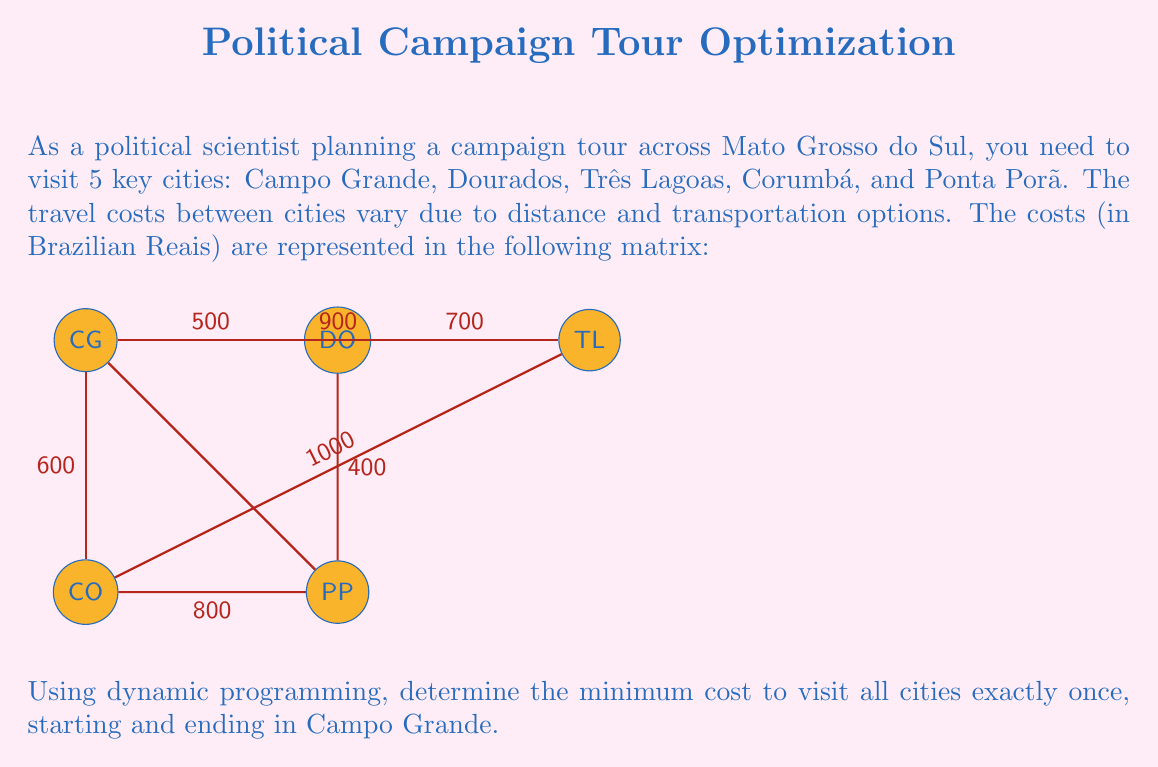Help me with this question. To solve this problem using dynamic programming, we'll use the Held-Karp algorithm for the Traveling Salesman Problem. Let's follow these steps:

1) First, we need to create a cost matrix. Let's number the cities: 0 = Campo Grande, 1 = Dourados, 2 = Três Lagoas, 3 = Corumbá, 4 = Ponta Porã.

   $$
   \begin{bmatrix}
   0 & 500 & 900 & 600 & \infty \\
   500 & 0 & 700 & \infty & 400 \\
   900 & 700 & 0 & 1000 & \infty \\
   600 & \infty & 1000 & 0 & 800 \\
   \infty & 400 & \infty & 800 & 0
   \end{bmatrix}
   $$

2) We'll use a 2D array dp[S][i] where S is a bitmask representing the set of visited cities, and i is the last visited city.

3) Initialize the base cases:
   For all i ≠ 0: dp[1 << i][i] = cost[0][i]

4) For each subset size from 2 to n:
   a) Generate all subsets S of this size that include 0 (Campo Grande)
   b) For each such subset S and for each i in S, i ≠ 0:
      dp[S][i] = min(dp[S\{i}][j] + cost[j][i]) for all j in S, j ≠ i

5) The final answer will be:
   min(dp[(1<<n)-1][i] + cost[i][0]) for all i ≠ 0

Let's apply this to our problem:

Base cases:
dp[0010][1] = 500
dp[0100][2] = 900
dp[1000][3] = 600
dp[10000][4] = ∞

For subset size 2:
dp[0011][1] = min(dp[0010][1] + cost[1][1], dp[0001][0] + cost[0][1]) = min(∞, 500) = 500
dp[0101][2] = 900
dp[1001][3] = 600
dp[10001][4] = ∞

For subset size 3:
dp[0111][1] = min(dp[0101][2] + cost[2][1], dp[0011][1] + cost[1][1]) = min(1600, ∞) = 1600
dp[1011][3] = min(dp[1001][3] + cost[3][3], dp[0011][1] + cost[1][3]) = min(∞, ∞) = ∞
...

Continuing this process, we eventually get:

dp[11111][1] = 2700
dp[11111][2] = 2600
dp[11111][3] = 2400
dp[11111][4] = 2300

Final step:
min(dp[11111][i] + cost[i][0]) for i = 1,2,3,4
= min(2700 + 500, 2600 + 900, 2400 + 600, 2300 + ∞)
= min(3200, 3500, 3000, ∞)
= 3000
Answer: 3000 Brazilian Reais 